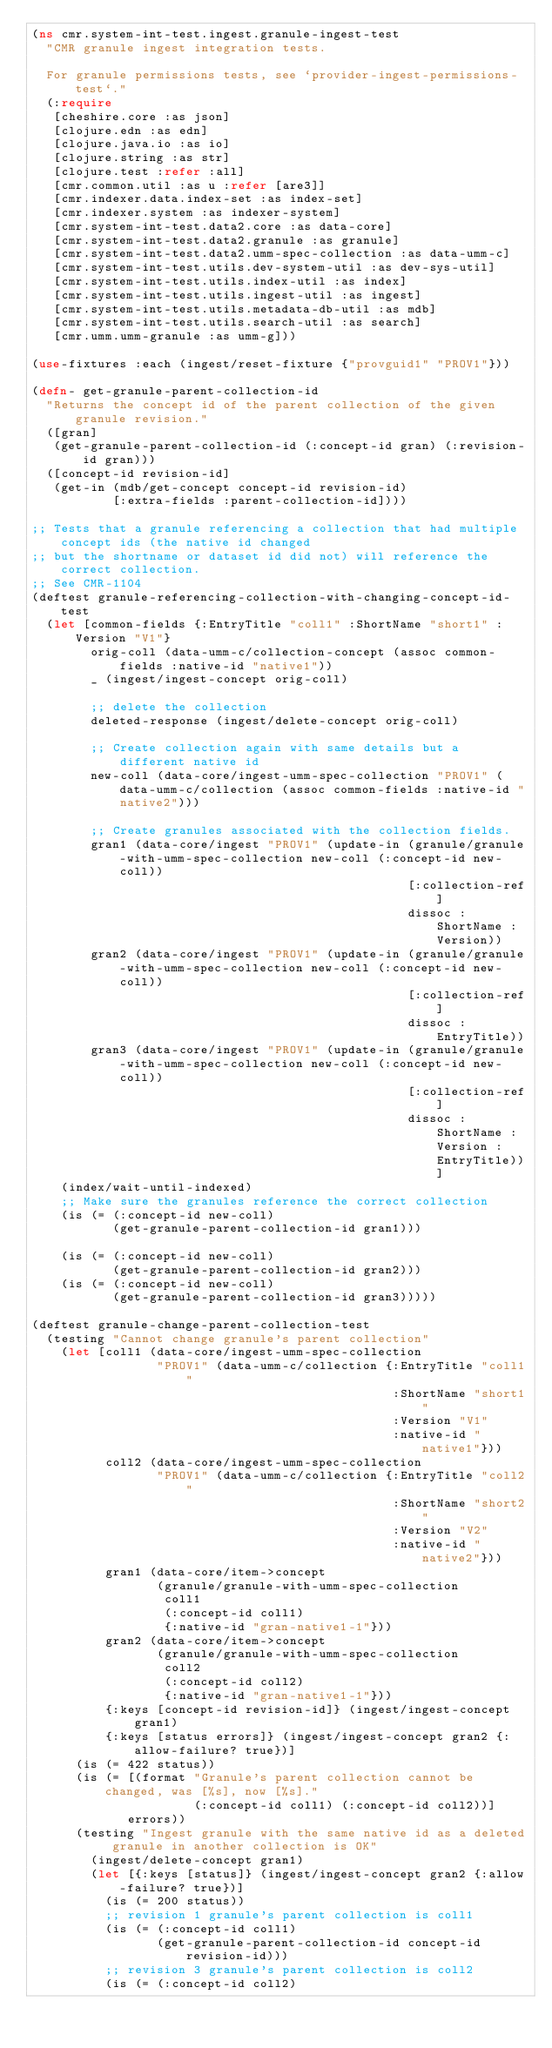<code> <loc_0><loc_0><loc_500><loc_500><_Clojure_>(ns cmr.system-int-test.ingest.granule-ingest-test
  "CMR granule ingest integration tests.

  For granule permissions tests, see `provider-ingest-permissions-test`."
  (:require
   [cheshire.core :as json]
   [clojure.edn :as edn]
   [clojure.java.io :as io]
   [clojure.string :as str]
   [clojure.test :refer :all]
   [cmr.common.util :as u :refer [are3]]
   [cmr.indexer.data.index-set :as index-set]
   [cmr.indexer.system :as indexer-system]
   [cmr.system-int-test.data2.core :as data-core]
   [cmr.system-int-test.data2.granule :as granule]
   [cmr.system-int-test.data2.umm-spec-collection :as data-umm-c]
   [cmr.system-int-test.utils.dev-system-util :as dev-sys-util]
   [cmr.system-int-test.utils.index-util :as index]
   [cmr.system-int-test.utils.ingest-util :as ingest]
   [cmr.system-int-test.utils.metadata-db-util :as mdb]
   [cmr.system-int-test.utils.search-util :as search]
   [cmr.umm.umm-granule :as umm-g]))

(use-fixtures :each (ingest/reset-fixture {"provguid1" "PROV1"}))

(defn- get-granule-parent-collection-id
  "Returns the concept id of the parent collection of the given granule revision."
  ([gran]
   (get-granule-parent-collection-id (:concept-id gran) (:revision-id gran)))
  ([concept-id revision-id]
   (get-in (mdb/get-concept concept-id revision-id)
           [:extra-fields :parent-collection-id])))

;; Tests that a granule referencing a collection that had multiple concept ids (the native id changed
;; but the shortname or dataset id did not) will reference the correct collection.
;; See CMR-1104
(deftest granule-referencing-collection-with-changing-concept-id-test
  (let [common-fields {:EntryTitle "coll1" :ShortName "short1" :Version "V1"}
        orig-coll (data-umm-c/collection-concept (assoc common-fields :native-id "native1"))
        _ (ingest/ingest-concept orig-coll)

        ;; delete the collection
        deleted-response (ingest/delete-concept orig-coll)

        ;; Create collection again with same details but a different native id
        new-coll (data-core/ingest-umm-spec-collection "PROV1" (data-umm-c/collection (assoc common-fields :native-id "native2")))

        ;; Create granules associated with the collection fields.
        gran1 (data-core/ingest "PROV1" (update-in (granule/granule-with-umm-spec-collection new-coll (:concept-id new-coll))
                                                   [:collection-ref]
                                                   dissoc :ShortName :Version))
        gran2 (data-core/ingest "PROV1" (update-in (granule/granule-with-umm-spec-collection new-coll (:concept-id new-coll))
                                                   [:collection-ref]
                                                   dissoc :EntryTitle))
        gran3 (data-core/ingest "PROV1" (update-in (granule/granule-with-umm-spec-collection new-coll (:concept-id new-coll))
                                                   [:collection-ref]
                                                   dissoc :ShortName :Version :EntryTitle))]
    (index/wait-until-indexed)
    ;; Make sure the granules reference the correct collection
    (is (= (:concept-id new-coll)
           (get-granule-parent-collection-id gran1)))

    (is (= (:concept-id new-coll)
           (get-granule-parent-collection-id gran2)))
    (is (= (:concept-id new-coll)
           (get-granule-parent-collection-id gran3)))))

(deftest granule-change-parent-collection-test
  (testing "Cannot change granule's parent collection"
    (let [coll1 (data-core/ingest-umm-spec-collection
                 "PROV1" (data-umm-c/collection {:EntryTitle "coll1"
                                                 :ShortName "short1"
                                                 :Version "V1"
                                                 :native-id "native1"}))
          coll2 (data-core/ingest-umm-spec-collection
                 "PROV1" (data-umm-c/collection {:EntryTitle "coll2"
                                                 :ShortName "short2"
                                                 :Version "V2"
                                                 :native-id "native2"}))
          gran1 (data-core/item->concept
                 (granule/granule-with-umm-spec-collection
                  coll1
                  (:concept-id coll1)
                  {:native-id "gran-native1-1"}))
          gran2 (data-core/item->concept
                 (granule/granule-with-umm-spec-collection
                  coll2
                  (:concept-id coll2)
                  {:native-id "gran-native1-1"}))
          {:keys [concept-id revision-id]} (ingest/ingest-concept gran1)
          {:keys [status errors]} (ingest/ingest-concept gran2 {:allow-failure? true})]
      (is (= 422 status))
      (is (= [(format "Granule's parent collection cannot be changed, was [%s], now [%s]."
                      (:concept-id coll1) (:concept-id coll2))]
             errors))
      (testing "Ingest granule with the same native id as a deleted granule in another collection is OK"
        (ingest/delete-concept gran1)
        (let [{:keys [status]} (ingest/ingest-concept gran2 {:allow-failure? true})]
          (is (= 200 status))
          ;; revision 1 granule's parent collection is coll1
          (is (= (:concept-id coll1)
                 (get-granule-parent-collection-id concept-id revision-id)))
          ;; revision 3 granule's parent collection is coll2
          (is (= (:concept-id coll2)</code> 